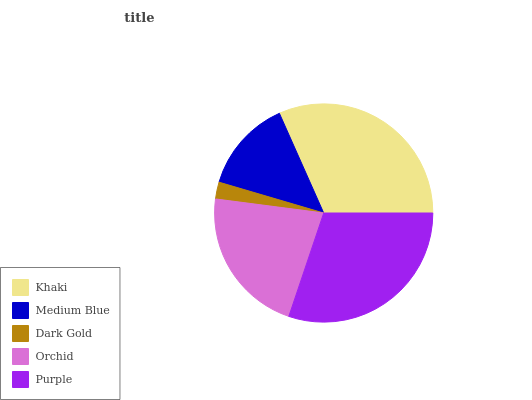Is Dark Gold the minimum?
Answer yes or no. Yes. Is Khaki the maximum?
Answer yes or no. Yes. Is Medium Blue the minimum?
Answer yes or no. No. Is Medium Blue the maximum?
Answer yes or no. No. Is Khaki greater than Medium Blue?
Answer yes or no. Yes. Is Medium Blue less than Khaki?
Answer yes or no. Yes. Is Medium Blue greater than Khaki?
Answer yes or no. No. Is Khaki less than Medium Blue?
Answer yes or no. No. Is Orchid the high median?
Answer yes or no. Yes. Is Orchid the low median?
Answer yes or no. Yes. Is Purple the high median?
Answer yes or no. No. Is Dark Gold the low median?
Answer yes or no. No. 